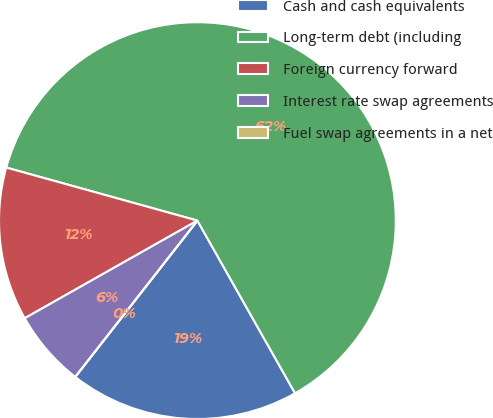<chart> <loc_0><loc_0><loc_500><loc_500><pie_chart><fcel>Cash and cash equivalents<fcel>Long-term debt (including<fcel>Foreign currency forward<fcel>Interest rate swap agreements<fcel>Fuel swap agreements in a net<nl><fcel>18.75%<fcel>62.5%<fcel>12.5%<fcel>6.25%<fcel>0.0%<nl></chart> 